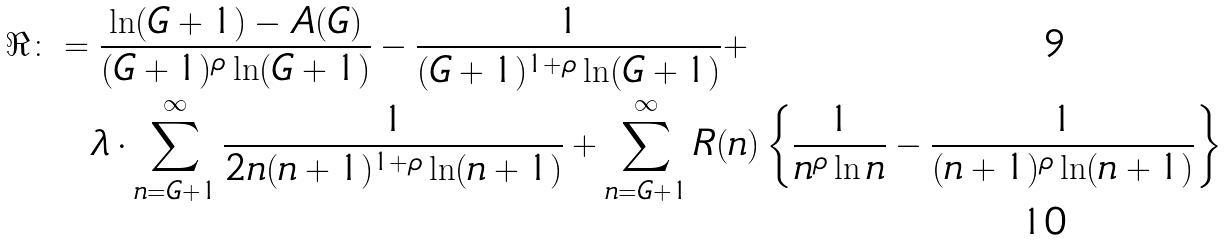Convert formula to latex. <formula><loc_0><loc_0><loc_500><loc_500>\Re & \colon = \frac { \ln ( G + 1 ) - A ( G ) } { ( G + 1 ) ^ { \rho } \ln ( G + 1 ) } - \frac { 1 } { ( G + 1 ) ^ { 1 + \rho } \ln ( G + 1 ) } + \\ & \quad \ \lambda \cdot \sum _ { n = G + 1 } ^ { \infty } \frac { 1 } { 2 n ( n + 1 ) ^ { 1 + \rho } \ln ( n + 1 ) } + \sum _ { n = G + 1 } ^ { \infty } R ( n ) \left \{ \frac { 1 } { n ^ { \rho } \ln n } - \frac { 1 } { ( n + 1 ) ^ { \rho } \ln ( n + 1 ) } \right \}</formula> 